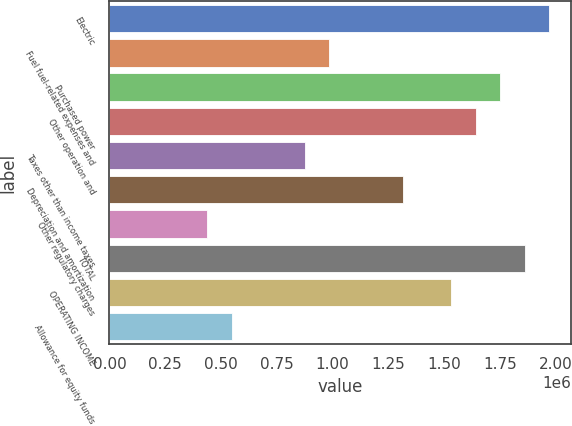Convert chart to OTSL. <chart><loc_0><loc_0><loc_500><loc_500><bar_chart><fcel>Electric<fcel>Fuel fuel-related expenses and<fcel>Purchased power<fcel>Other operation and<fcel>Taxes other than income taxes<fcel>Depreciation and amortization<fcel>Other regulatory charges<fcel>TOTAL<fcel>OPERATING INCOME<fcel>Allowance for equity funds<nl><fcel>1.96984e+06<fcel>985250<fcel>1.75104e+06<fcel>1.64165e+06<fcel>875850<fcel>1.31345e+06<fcel>438253<fcel>1.86044e+06<fcel>1.53225e+06<fcel>547652<nl></chart> 